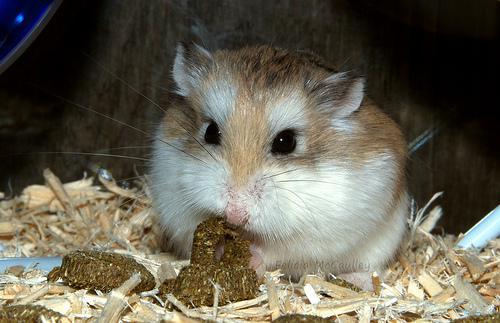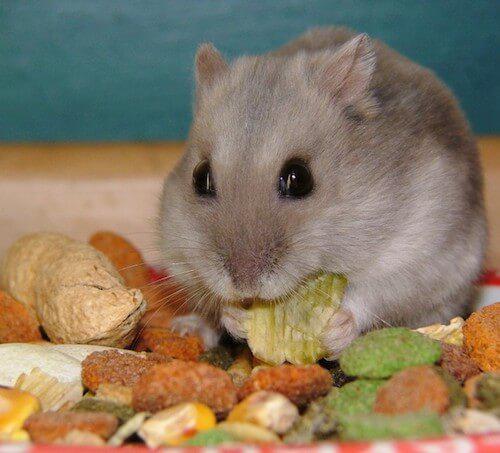The first image is the image on the left, the second image is the image on the right. Given the left and right images, does the statement "The rodent in the image on the right has a piece of broccoli in front of it." hold true? Answer yes or no. No. The first image is the image on the left, the second image is the image on the right. Given the left and right images, does the statement "A bright green broccoli floret is in front of a pet rodent." hold true? Answer yes or no. No. 